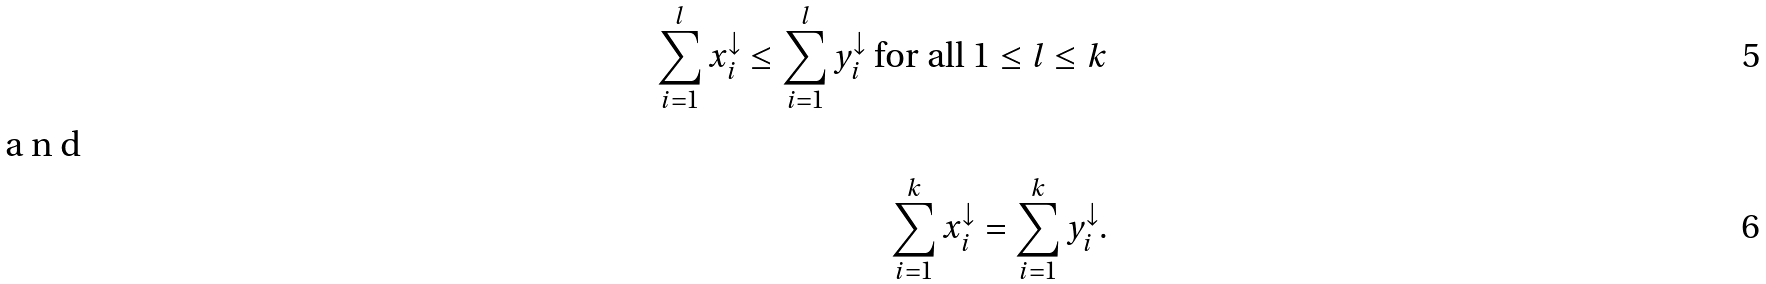Convert formula to latex. <formula><loc_0><loc_0><loc_500><loc_500>\sum ^ { l } _ { i = 1 } x ^ { \downarrow } _ { i } \leq \sum ^ { l } _ { i = 1 } y ^ { \downarrow } _ { i } \text { for all } 1 \leq l \leq k \\ \intertext { a n d } \sum ^ { k } _ { i = 1 } x ^ { \downarrow } _ { i } = \sum ^ { k } _ { i = 1 } y ^ { \downarrow } _ { i } .</formula> 